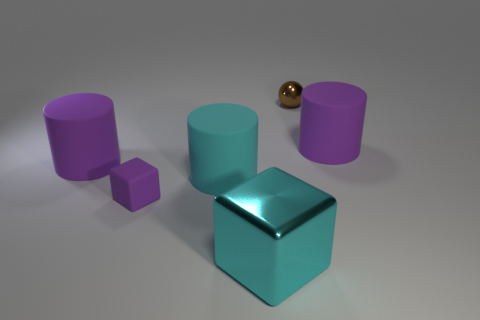Subtract all yellow cubes. How many purple cylinders are left? 2 Subtract 1 cylinders. How many cylinders are left? 2 Subtract all purple cylinders. How many cylinders are left? 1 Add 3 tiny metallic things. How many objects exist? 9 Subtract all spheres. How many objects are left? 5 Add 3 small cylinders. How many small cylinders exist? 3 Subtract 0 blue spheres. How many objects are left? 6 Subtract all cyan metal cubes. Subtract all tiny rubber things. How many objects are left? 4 Add 2 small brown things. How many small brown things are left? 3 